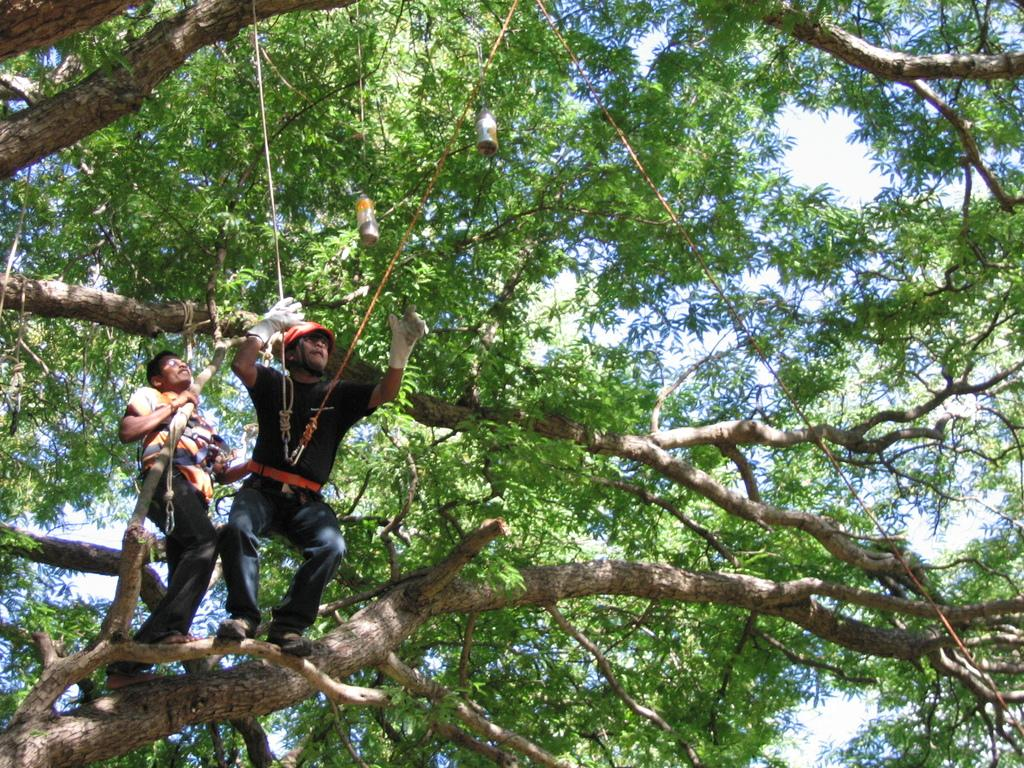What are the persons in the image doing? The persons in the image are standing on the branch of a tree. What are the persons holding in the image? The persons are holding robes. What can be seen in the background of the image? There are trees and bird feeders in the background of the image. What is visible in the sky in the image? The sky is visible in the background of the image. What type of vein can be seen running through the tree branch in the image? There is no vein visible in the image, as veins are not present in trees or tree branches. How does the friction between the persons and the tree branch affect their balance in the image? There is no information about friction or balance in the image, so it cannot be determined from the image. 